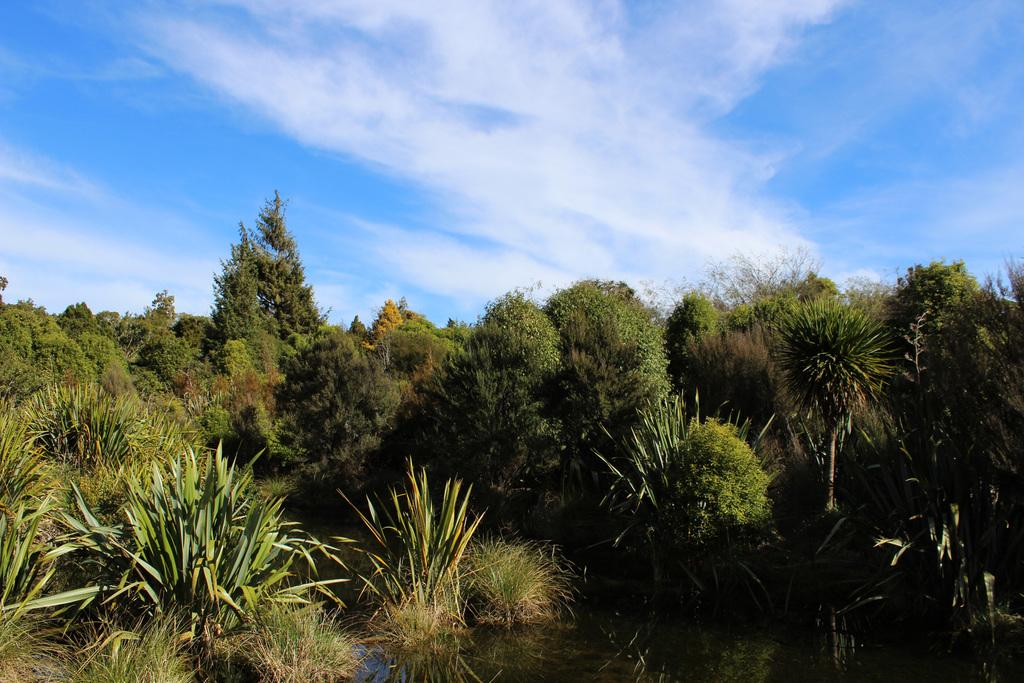What type of body of water is present in the image? There is a lake in the picture. What type of vegetation can be seen in the image? There is grass, plants, and trees in the picture. What is the condition of the sky in the image? The sky is clear in the image. What book is the person reading by the lake in the image? There is no person or book present in the image; it only features a lake, grass, plants, trees, and a clear sky. 